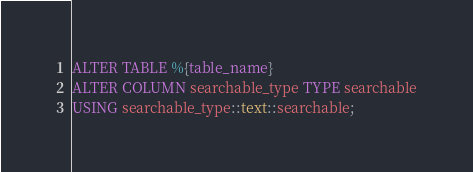<code> <loc_0><loc_0><loc_500><loc_500><_SQL_>ALTER TABLE %{table_name}
ALTER COLUMN searchable_type TYPE searchable
USING searchable_type::text::searchable;
</code> 